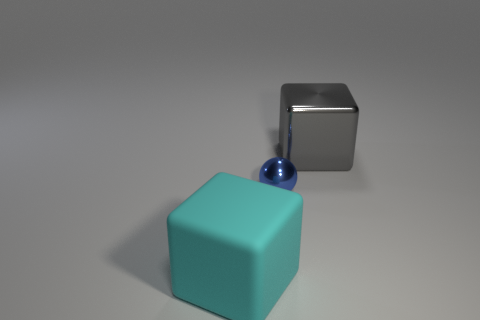Are there an equal number of blue metal balls that are left of the cyan matte block and green shiny balls?
Your answer should be compact. Yes. Are there any rubber cubes of the same color as the sphere?
Your answer should be compact. No. Is the size of the rubber cube the same as the blue thing?
Make the answer very short. No. There is a sphere that is left of the cube right of the cyan cube; how big is it?
Give a very brief answer. Small. What is the size of the thing that is both left of the large gray shiny cube and behind the cyan thing?
Ensure brevity in your answer.  Small. How many gray cubes are the same size as the cyan matte cube?
Provide a succinct answer. 1. How many rubber things are either large purple cylinders or tiny blue balls?
Your answer should be very brief. 0. What is the material of the large thing that is on the right side of the big object that is on the left side of the gray shiny thing?
Keep it short and to the point. Metal. How many things are either tiny cyan spheres or cubes in front of the metallic ball?
Provide a short and direct response. 1. There is a sphere that is made of the same material as the large gray block; what size is it?
Provide a succinct answer. Small. 